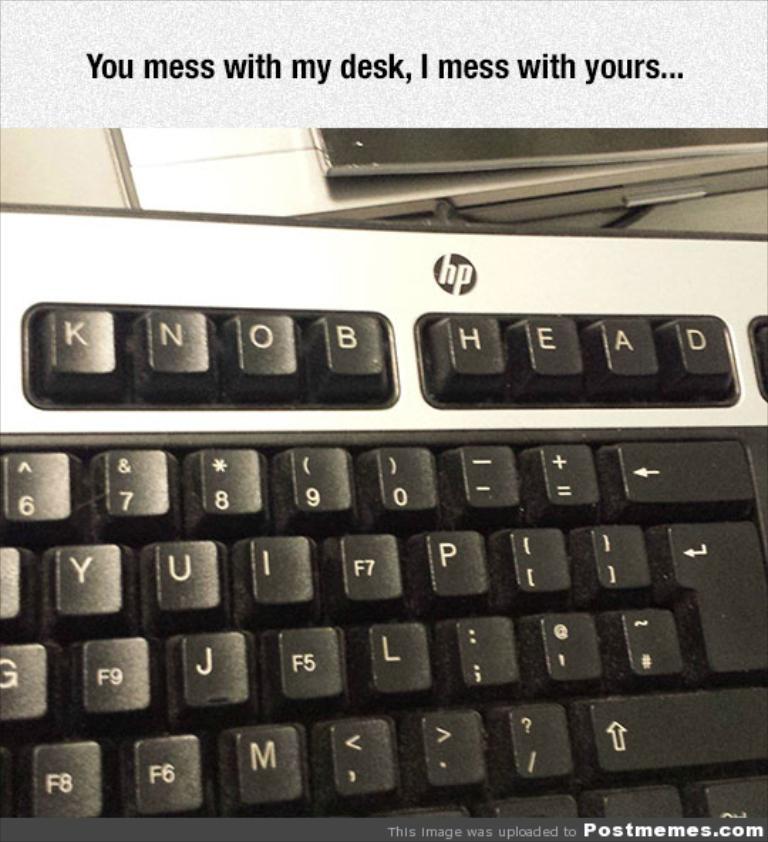What is the brand of the keyboard?
Offer a very short reply. Hp. What do the top four keys say?
Ensure brevity in your answer.  Knob. 